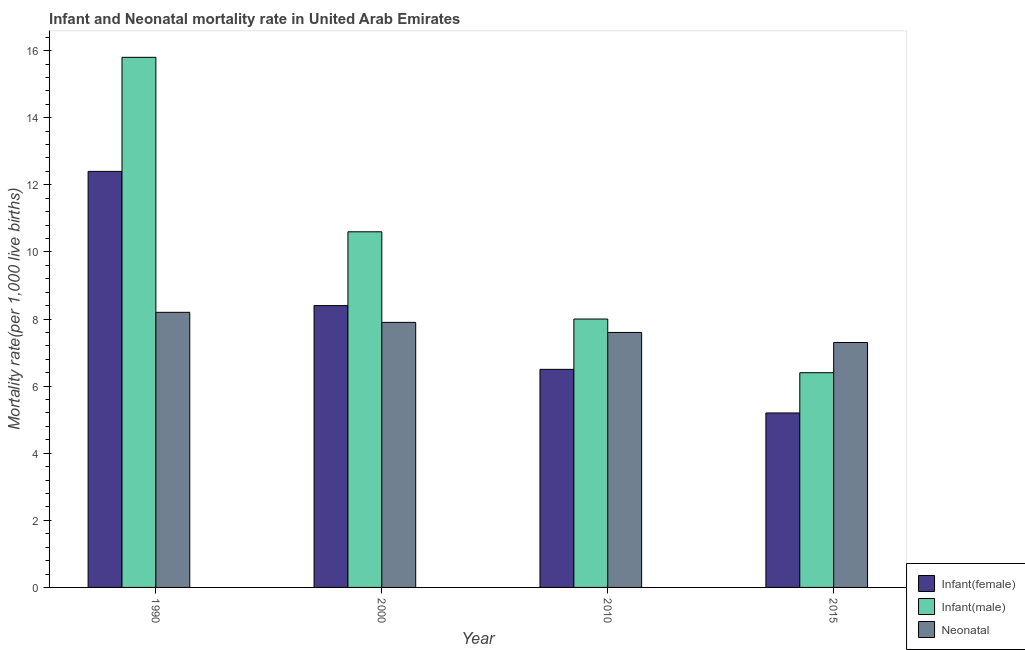Are the number of bars on each tick of the X-axis equal?
Provide a succinct answer. Yes. How many bars are there on the 1st tick from the right?
Give a very brief answer. 3. What is the label of the 4th group of bars from the left?
Provide a succinct answer. 2015. In how many cases, is the number of bars for a given year not equal to the number of legend labels?
Your response must be concise. 0. What is the infant mortality rate(female) in 2010?
Give a very brief answer. 6.5. Across all years, what is the maximum infant mortality rate(male)?
Your answer should be very brief. 15.8. In which year was the neonatal mortality rate maximum?
Offer a very short reply. 1990. In which year was the infant mortality rate(female) minimum?
Provide a succinct answer. 2015. What is the total infant mortality rate(female) in the graph?
Give a very brief answer. 32.5. What is the difference between the neonatal mortality rate in 2000 and the infant mortality rate(male) in 1990?
Offer a terse response. -0.3. What is the average infant mortality rate(male) per year?
Your answer should be very brief. 10.2. In the year 1990, what is the difference between the neonatal mortality rate and infant mortality rate(male)?
Your answer should be compact. 0. In how many years, is the infant mortality rate(female) greater than 4.4?
Provide a succinct answer. 4. What is the ratio of the infant mortality rate(female) in 2000 to that in 2015?
Your response must be concise. 1.62. Is the infant mortality rate(female) in 2000 less than that in 2015?
Provide a short and direct response. No. Is the difference between the neonatal mortality rate in 2000 and 2010 greater than the difference between the infant mortality rate(female) in 2000 and 2010?
Your response must be concise. No. What is the difference between the highest and the second highest infant mortality rate(female)?
Make the answer very short. 4. In how many years, is the neonatal mortality rate greater than the average neonatal mortality rate taken over all years?
Offer a very short reply. 2. What does the 3rd bar from the left in 2000 represents?
Provide a succinct answer. Neonatal . What does the 1st bar from the right in 2000 represents?
Keep it short and to the point. Neonatal . Is it the case that in every year, the sum of the infant mortality rate(female) and infant mortality rate(male) is greater than the neonatal mortality rate?
Your response must be concise. Yes. Does the graph contain any zero values?
Provide a short and direct response. No. Does the graph contain grids?
Provide a succinct answer. No. How are the legend labels stacked?
Your response must be concise. Vertical. What is the title of the graph?
Make the answer very short. Infant and Neonatal mortality rate in United Arab Emirates. What is the label or title of the Y-axis?
Ensure brevity in your answer.  Mortality rate(per 1,0 live births). What is the Mortality rate(per 1,000 live births) in Infant(female) in 1990?
Your response must be concise. 12.4. What is the Mortality rate(per 1,000 live births) in Neonatal  in 1990?
Make the answer very short. 8.2. What is the Mortality rate(per 1,000 live births) of Neonatal  in 2000?
Make the answer very short. 7.9. What is the Mortality rate(per 1,000 live births) in Infant(female) in 2015?
Offer a terse response. 5.2. What is the Mortality rate(per 1,000 live births) of Infant(male) in 2015?
Offer a very short reply. 6.4. Across all years, what is the minimum Mortality rate(per 1,000 live births) of Infant(female)?
Provide a succinct answer. 5.2. Across all years, what is the minimum Mortality rate(per 1,000 live births) of Infant(male)?
Provide a succinct answer. 6.4. What is the total Mortality rate(per 1,000 live births) in Infant(female) in the graph?
Offer a terse response. 32.5. What is the total Mortality rate(per 1,000 live births) in Infant(male) in the graph?
Offer a very short reply. 40.8. What is the difference between the Mortality rate(per 1,000 live births) of Infant(male) in 1990 and that in 2000?
Give a very brief answer. 5.2. What is the difference between the Mortality rate(per 1,000 live births) of Infant(male) in 1990 and that in 2015?
Provide a succinct answer. 9.4. What is the difference between the Mortality rate(per 1,000 live births) in Neonatal  in 1990 and that in 2015?
Your answer should be very brief. 0.9. What is the difference between the Mortality rate(per 1,000 live births) of Infant(female) in 2000 and that in 2010?
Keep it short and to the point. 1.9. What is the difference between the Mortality rate(per 1,000 live births) of Infant(male) in 2000 and that in 2010?
Give a very brief answer. 2.6. What is the difference between the Mortality rate(per 1,000 live births) in Neonatal  in 2000 and that in 2010?
Your answer should be compact. 0.3. What is the difference between the Mortality rate(per 1,000 live births) in Infant(female) in 2000 and that in 2015?
Provide a succinct answer. 3.2. What is the difference between the Mortality rate(per 1,000 live births) of Neonatal  in 2000 and that in 2015?
Your response must be concise. 0.6. What is the difference between the Mortality rate(per 1,000 live births) in Infant(male) in 2010 and that in 2015?
Provide a succinct answer. 1.6. What is the difference between the Mortality rate(per 1,000 live births) in Infant(female) in 1990 and the Mortality rate(per 1,000 live births) in Infant(male) in 2000?
Make the answer very short. 1.8. What is the difference between the Mortality rate(per 1,000 live births) in Infant(female) in 1990 and the Mortality rate(per 1,000 live births) in Neonatal  in 2000?
Your answer should be compact. 4.5. What is the difference between the Mortality rate(per 1,000 live births) in Infant(female) in 1990 and the Mortality rate(per 1,000 live births) in Infant(male) in 2010?
Make the answer very short. 4.4. What is the difference between the Mortality rate(per 1,000 live births) in Infant(female) in 1990 and the Mortality rate(per 1,000 live births) in Neonatal  in 2010?
Your answer should be very brief. 4.8. What is the difference between the Mortality rate(per 1,000 live births) in Infant(female) in 1990 and the Mortality rate(per 1,000 live births) in Infant(male) in 2015?
Give a very brief answer. 6. What is the difference between the Mortality rate(per 1,000 live births) in Infant(female) in 2000 and the Mortality rate(per 1,000 live births) in Infant(male) in 2010?
Ensure brevity in your answer.  0.4. What is the difference between the Mortality rate(per 1,000 live births) in Infant(female) in 2000 and the Mortality rate(per 1,000 live births) in Infant(male) in 2015?
Provide a succinct answer. 2. What is the difference between the Mortality rate(per 1,000 live births) in Infant(female) in 2000 and the Mortality rate(per 1,000 live births) in Neonatal  in 2015?
Keep it short and to the point. 1.1. What is the difference between the Mortality rate(per 1,000 live births) of Infant(female) in 2010 and the Mortality rate(per 1,000 live births) of Infant(male) in 2015?
Your response must be concise. 0.1. What is the difference between the Mortality rate(per 1,000 live births) of Infant(female) in 2010 and the Mortality rate(per 1,000 live births) of Neonatal  in 2015?
Your answer should be compact. -0.8. What is the average Mortality rate(per 1,000 live births) of Infant(female) per year?
Give a very brief answer. 8.12. What is the average Mortality rate(per 1,000 live births) of Neonatal  per year?
Provide a short and direct response. 7.75. In the year 1990, what is the difference between the Mortality rate(per 1,000 live births) in Infant(female) and Mortality rate(per 1,000 live births) in Infant(male)?
Your answer should be compact. -3.4. In the year 2000, what is the difference between the Mortality rate(per 1,000 live births) in Infant(female) and Mortality rate(per 1,000 live births) in Neonatal ?
Give a very brief answer. 0.5. In the year 2000, what is the difference between the Mortality rate(per 1,000 live births) in Infant(male) and Mortality rate(per 1,000 live births) in Neonatal ?
Provide a short and direct response. 2.7. In the year 2015, what is the difference between the Mortality rate(per 1,000 live births) in Infant(female) and Mortality rate(per 1,000 live births) in Infant(male)?
Provide a short and direct response. -1.2. In the year 2015, what is the difference between the Mortality rate(per 1,000 live births) in Infant(female) and Mortality rate(per 1,000 live births) in Neonatal ?
Give a very brief answer. -2.1. What is the ratio of the Mortality rate(per 1,000 live births) of Infant(female) in 1990 to that in 2000?
Offer a very short reply. 1.48. What is the ratio of the Mortality rate(per 1,000 live births) in Infant(male) in 1990 to that in 2000?
Offer a very short reply. 1.49. What is the ratio of the Mortality rate(per 1,000 live births) in Neonatal  in 1990 to that in 2000?
Your answer should be compact. 1.04. What is the ratio of the Mortality rate(per 1,000 live births) of Infant(female) in 1990 to that in 2010?
Ensure brevity in your answer.  1.91. What is the ratio of the Mortality rate(per 1,000 live births) in Infant(male) in 1990 to that in 2010?
Ensure brevity in your answer.  1.98. What is the ratio of the Mortality rate(per 1,000 live births) in Neonatal  in 1990 to that in 2010?
Your answer should be very brief. 1.08. What is the ratio of the Mortality rate(per 1,000 live births) in Infant(female) in 1990 to that in 2015?
Keep it short and to the point. 2.38. What is the ratio of the Mortality rate(per 1,000 live births) in Infant(male) in 1990 to that in 2015?
Provide a short and direct response. 2.47. What is the ratio of the Mortality rate(per 1,000 live births) of Neonatal  in 1990 to that in 2015?
Give a very brief answer. 1.12. What is the ratio of the Mortality rate(per 1,000 live births) of Infant(female) in 2000 to that in 2010?
Give a very brief answer. 1.29. What is the ratio of the Mortality rate(per 1,000 live births) of Infant(male) in 2000 to that in 2010?
Your response must be concise. 1.32. What is the ratio of the Mortality rate(per 1,000 live births) of Neonatal  in 2000 to that in 2010?
Keep it short and to the point. 1.04. What is the ratio of the Mortality rate(per 1,000 live births) of Infant(female) in 2000 to that in 2015?
Your answer should be very brief. 1.62. What is the ratio of the Mortality rate(per 1,000 live births) of Infant(male) in 2000 to that in 2015?
Make the answer very short. 1.66. What is the ratio of the Mortality rate(per 1,000 live births) of Neonatal  in 2000 to that in 2015?
Offer a terse response. 1.08. What is the ratio of the Mortality rate(per 1,000 live births) of Infant(female) in 2010 to that in 2015?
Make the answer very short. 1.25. What is the ratio of the Mortality rate(per 1,000 live births) in Neonatal  in 2010 to that in 2015?
Provide a short and direct response. 1.04. What is the difference between the highest and the second highest Mortality rate(per 1,000 live births) of Infant(male)?
Provide a succinct answer. 5.2. 